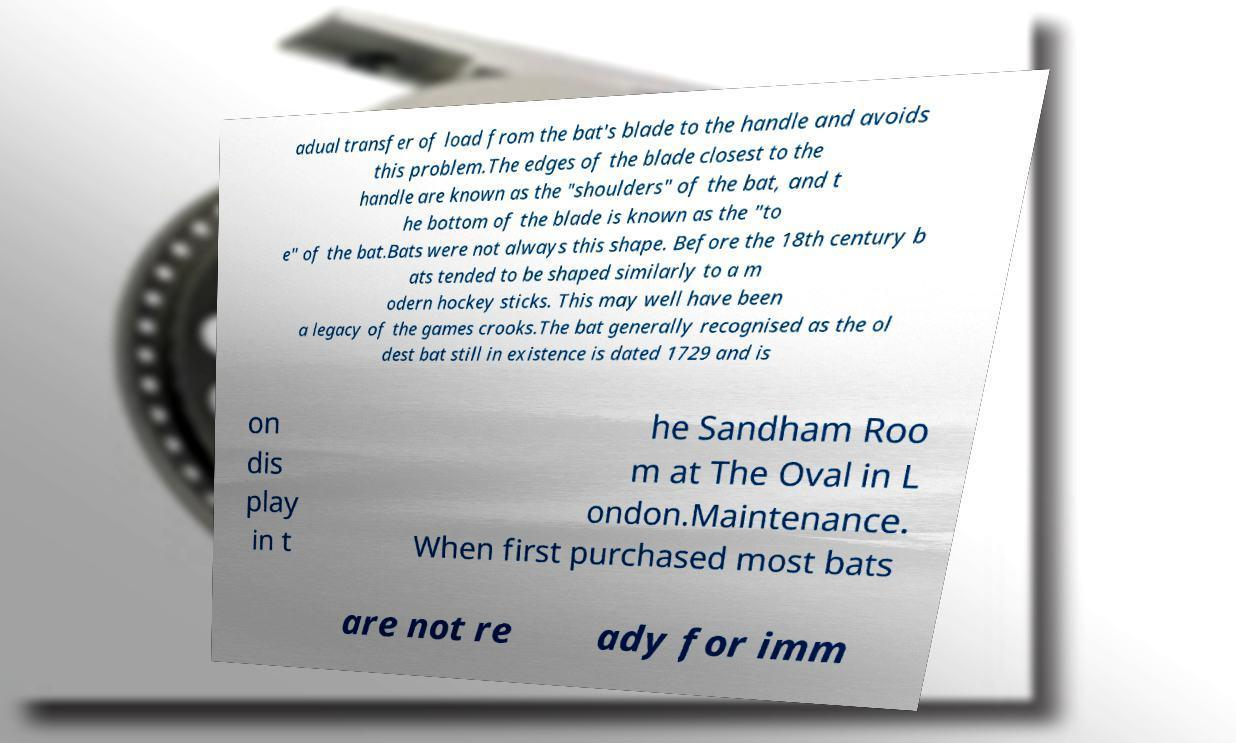For documentation purposes, I need the text within this image transcribed. Could you provide that? adual transfer of load from the bat's blade to the handle and avoids this problem.The edges of the blade closest to the handle are known as the "shoulders" of the bat, and t he bottom of the blade is known as the "to e" of the bat.Bats were not always this shape. Before the 18th century b ats tended to be shaped similarly to a m odern hockey sticks. This may well have been a legacy of the games crooks.The bat generally recognised as the ol dest bat still in existence is dated 1729 and is on dis play in t he Sandham Roo m at The Oval in L ondon.Maintenance. When first purchased most bats are not re ady for imm 